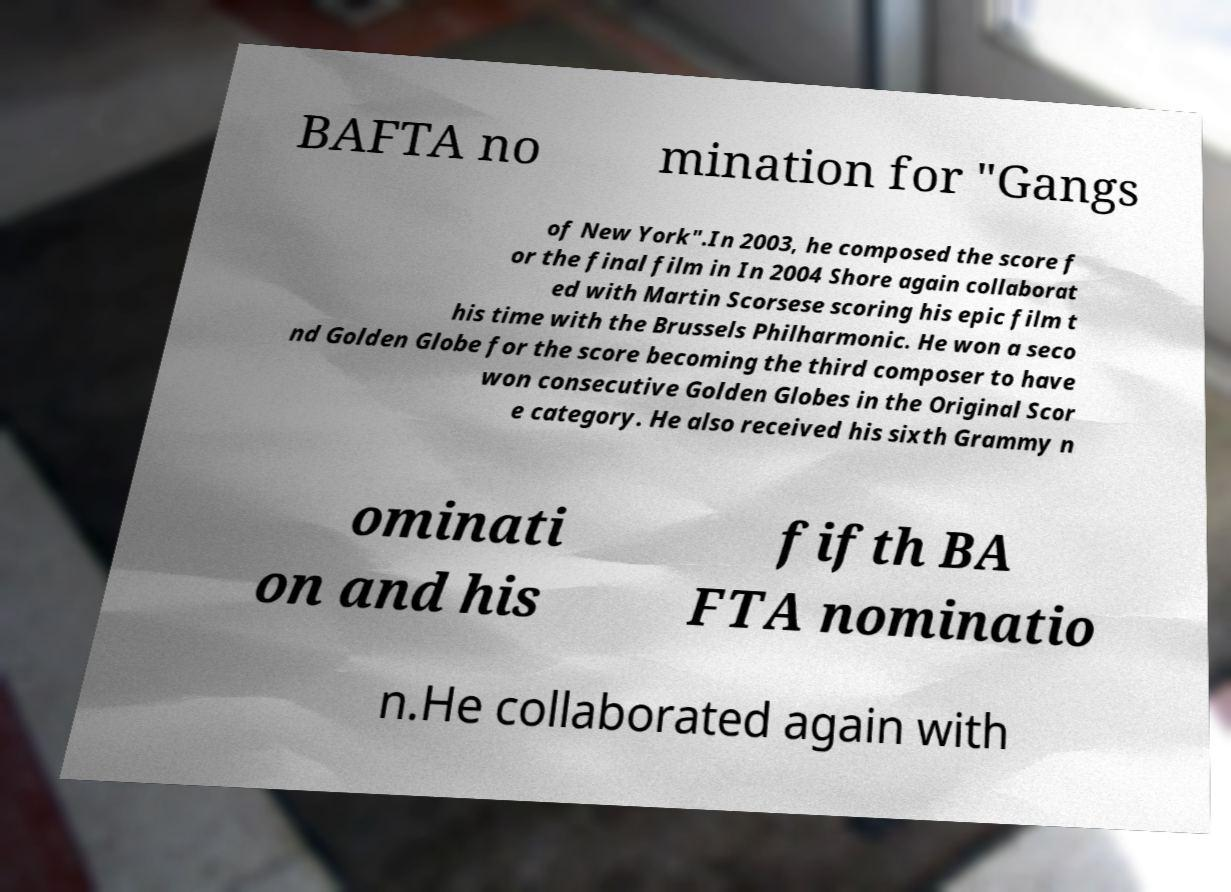Could you extract and type out the text from this image? BAFTA no mination for "Gangs of New York".In 2003, he composed the score f or the final film in In 2004 Shore again collaborat ed with Martin Scorsese scoring his epic film t his time with the Brussels Philharmonic. He won a seco nd Golden Globe for the score becoming the third composer to have won consecutive Golden Globes in the Original Scor e category. He also received his sixth Grammy n ominati on and his fifth BA FTA nominatio n.He collaborated again with 